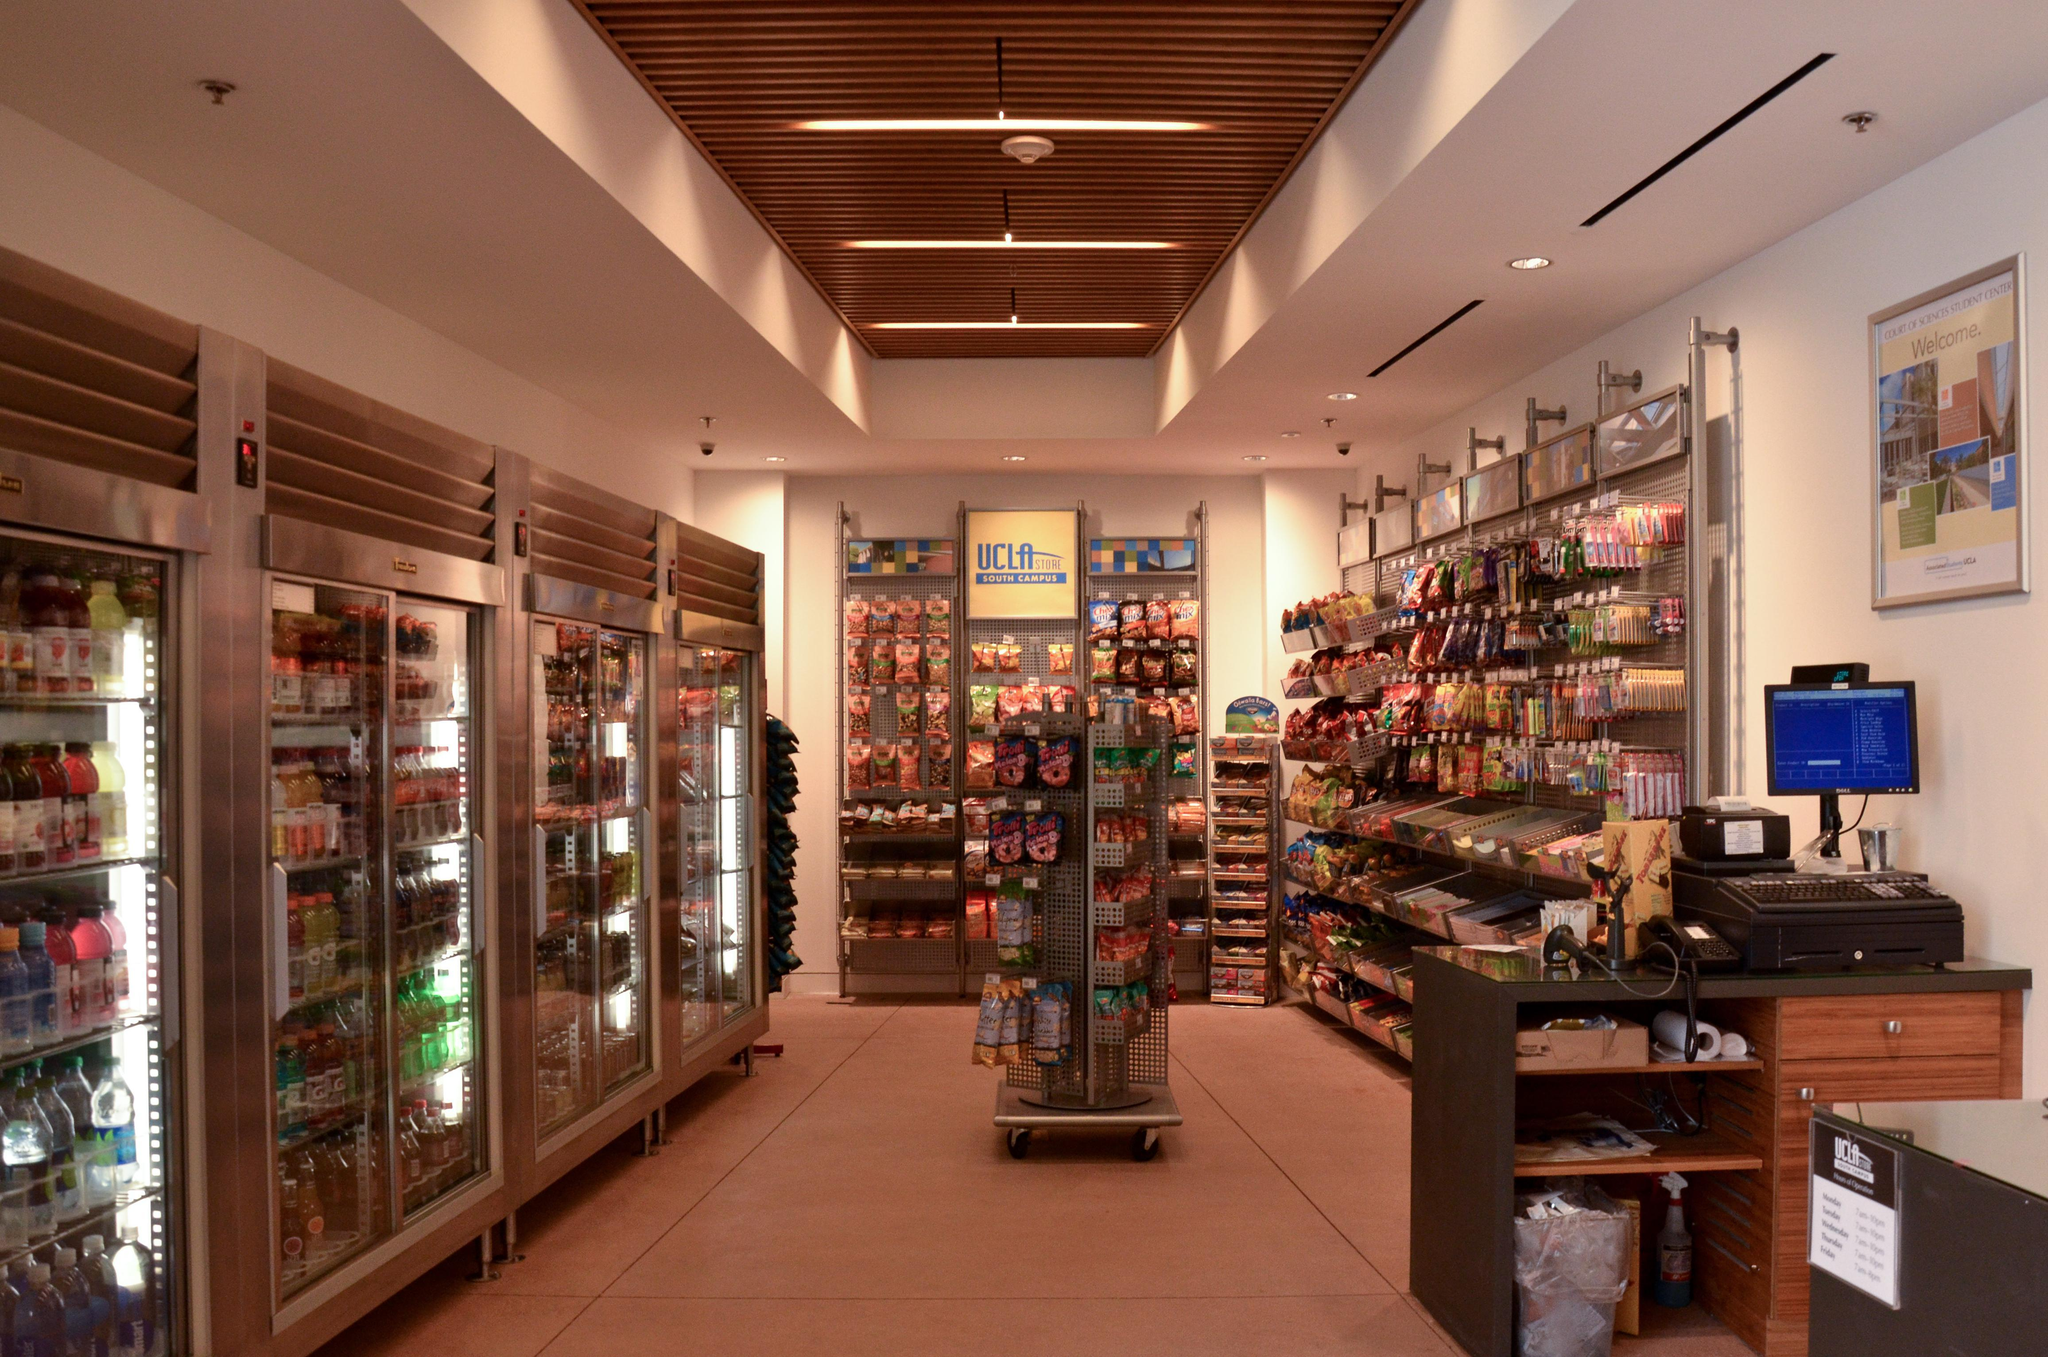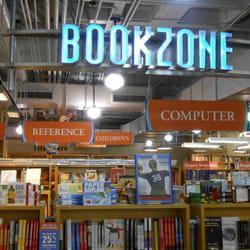The first image is the image on the left, the second image is the image on the right. Analyze the images presented: Is the assertion "There is a thin and tall standalone bookshelf in the centre of the left image." valid? Answer yes or no. Yes. 